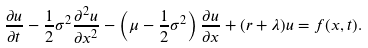<formula> <loc_0><loc_0><loc_500><loc_500>\frac { \partial u } { \partial t } - \frac { 1 } { 2 } \sigma ^ { 2 } \frac { \partial ^ { 2 } u } { \partial x ^ { 2 } } - \left ( \mu - \frac { 1 } { 2 } \sigma ^ { 2 } \right ) \frac { \partial u } { \partial x } + ( r + \lambda ) u = f ( x , t ) .</formula> 